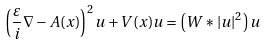Convert formula to latex. <formula><loc_0><loc_0><loc_500><loc_500>\left ( \frac { \varepsilon } { i } \nabla - A ( x ) \right ) ^ { 2 } u + V ( x ) u = \left ( W * | u | ^ { 2 } \right ) u</formula> 